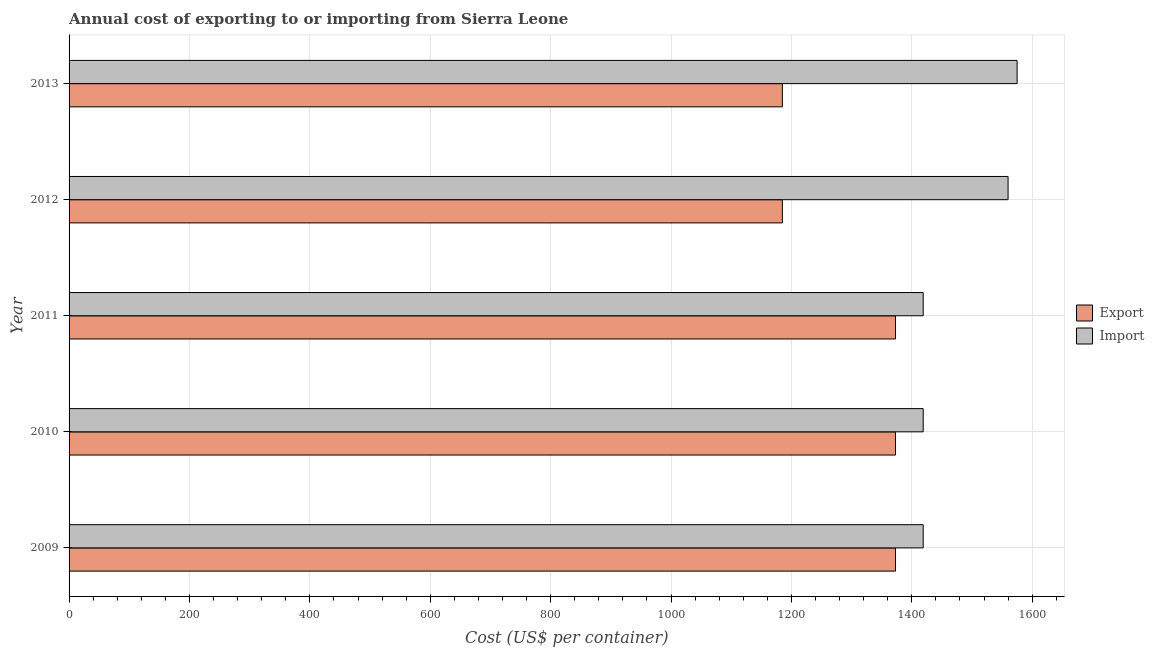How many different coloured bars are there?
Make the answer very short. 2. Are the number of bars per tick equal to the number of legend labels?
Your answer should be very brief. Yes. What is the label of the 5th group of bars from the top?
Offer a very short reply. 2009. What is the import cost in 2011?
Keep it short and to the point. 1419. Across all years, what is the maximum export cost?
Give a very brief answer. 1373. Across all years, what is the minimum import cost?
Give a very brief answer. 1419. What is the total import cost in the graph?
Provide a short and direct response. 7392. What is the difference between the export cost in 2010 and that in 2013?
Your answer should be compact. 188. What is the difference between the import cost in 2010 and the export cost in 2013?
Ensure brevity in your answer.  234. What is the average import cost per year?
Offer a very short reply. 1478.4. In the year 2013, what is the difference between the export cost and import cost?
Make the answer very short. -390. In how many years, is the import cost greater than 1600 US$?
Ensure brevity in your answer.  0. What is the ratio of the import cost in 2010 to that in 2011?
Give a very brief answer. 1. What is the difference between the highest and the lowest import cost?
Give a very brief answer. 156. In how many years, is the import cost greater than the average import cost taken over all years?
Ensure brevity in your answer.  2. What does the 1st bar from the top in 2009 represents?
Provide a succinct answer. Import. What does the 2nd bar from the bottom in 2013 represents?
Ensure brevity in your answer.  Import. Are the values on the major ticks of X-axis written in scientific E-notation?
Give a very brief answer. No. Does the graph contain grids?
Provide a short and direct response. Yes. How many legend labels are there?
Keep it short and to the point. 2. How are the legend labels stacked?
Your answer should be compact. Vertical. What is the title of the graph?
Offer a terse response. Annual cost of exporting to or importing from Sierra Leone. Does "Drinking water services" appear as one of the legend labels in the graph?
Offer a terse response. No. What is the label or title of the X-axis?
Keep it short and to the point. Cost (US$ per container). What is the Cost (US$ per container) of Export in 2009?
Make the answer very short. 1373. What is the Cost (US$ per container) in Import in 2009?
Provide a short and direct response. 1419. What is the Cost (US$ per container) in Export in 2010?
Offer a terse response. 1373. What is the Cost (US$ per container) in Import in 2010?
Offer a terse response. 1419. What is the Cost (US$ per container) of Export in 2011?
Provide a succinct answer. 1373. What is the Cost (US$ per container) in Import in 2011?
Provide a short and direct response. 1419. What is the Cost (US$ per container) of Export in 2012?
Offer a very short reply. 1185. What is the Cost (US$ per container) of Import in 2012?
Make the answer very short. 1560. What is the Cost (US$ per container) of Export in 2013?
Offer a terse response. 1185. What is the Cost (US$ per container) of Import in 2013?
Make the answer very short. 1575. Across all years, what is the maximum Cost (US$ per container) in Export?
Ensure brevity in your answer.  1373. Across all years, what is the maximum Cost (US$ per container) in Import?
Make the answer very short. 1575. Across all years, what is the minimum Cost (US$ per container) in Export?
Make the answer very short. 1185. Across all years, what is the minimum Cost (US$ per container) of Import?
Provide a succinct answer. 1419. What is the total Cost (US$ per container) of Export in the graph?
Offer a very short reply. 6489. What is the total Cost (US$ per container) in Import in the graph?
Ensure brevity in your answer.  7392. What is the difference between the Cost (US$ per container) of Export in 2009 and that in 2011?
Keep it short and to the point. 0. What is the difference between the Cost (US$ per container) of Export in 2009 and that in 2012?
Ensure brevity in your answer.  188. What is the difference between the Cost (US$ per container) in Import in 2009 and that in 2012?
Offer a very short reply. -141. What is the difference between the Cost (US$ per container) of Export in 2009 and that in 2013?
Make the answer very short. 188. What is the difference between the Cost (US$ per container) of Import in 2009 and that in 2013?
Ensure brevity in your answer.  -156. What is the difference between the Cost (US$ per container) in Export in 2010 and that in 2011?
Offer a terse response. 0. What is the difference between the Cost (US$ per container) of Import in 2010 and that in 2011?
Provide a succinct answer. 0. What is the difference between the Cost (US$ per container) in Export in 2010 and that in 2012?
Offer a terse response. 188. What is the difference between the Cost (US$ per container) in Import in 2010 and that in 2012?
Give a very brief answer. -141. What is the difference between the Cost (US$ per container) of Export in 2010 and that in 2013?
Give a very brief answer. 188. What is the difference between the Cost (US$ per container) in Import in 2010 and that in 2013?
Offer a terse response. -156. What is the difference between the Cost (US$ per container) of Export in 2011 and that in 2012?
Your response must be concise. 188. What is the difference between the Cost (US$ per container) of Import in 2011 and that in 2012?
Your answer should be compact. -141. What is the difference between the Cost (US$ per container) of Export in 2011 and that in 2013?
Give a very brief answer. 188. What is the difference between the Cost (US$ per container) in Import in 2011 and that in 2013?
Provide a short and direct response. -156. What is the difference between the Cost (US$ per container) of Export in 2012 and that in 2013?
Your answer should be compact. 0. What is the difference between the Cost (US$ per container) of Import in 2012 and that in 2013?
Make the answer very short. -15. What is the difference between the Cost (US$ per container) of Export in 2009 and the Cost (US$ per container) of Import in 2010?
Offer a terse response. -46. What is the difference between the Cost (US$ per container) of Export in 2009 and the Cost (US$ per container) of Import in 2011?
Make the answer very short. -46. What is the difference between the Cost (US$ per container) of Export in 2009 and the Cost (US$ per container) of Import in 2012?
Make the answer very short. -187. What is the difference between the Cost (US$ per container) in Export in 2009 and the Cost (US$ per container) in Import in 2013?
Offer a terse response. -202. What is the difference between the Cost (US$ per container) of Export in 2010 and the Cost (US$ per container) of Import in 2011?
Keep it short and to the point. -46. What is the difference between the Cost (US$ per container) in Export in 2010 and the Cost (US$ per container) in Import in 2012?
Offer a terse response. -187. What is the difference between the Cost (US$ per container) of Export in 2010 and the Cost (US$ per container) of Import in 2013?
Keep it short and to the point. -202. What is the difference between the Cost (US$ per container) of Export in 2011 and the Cost (US$ per container) of Import in 2012?
Your answer should be very brief. -187. What is the difference between the Cost (US$ per container) of Export in 2011 and the Cost (US$ per container) of Import in 2013?
Keep it short and to the point. -202. What is the difference between the Cost (US$ per container) of Export in 2012 and the Cost (US$ per container) of Import in 2013?
Ensure brevity in your answer.  -390. What is the average Cost (US$ per container) of Export per year?
Provide a short and direct response. 1297.8. What is the average Cost (US$ per container) of Import per year?
Your answer should be very brief. 1478.4. In the year 2009, what is the difference between the Cost (US$ per container) in Export and Cost (US$ per container) in Import?
Your answer should be compact. -46. In the year 2010, what is the difference between the Cost (US$ per container) of Export and Cost (US$ per container) of Import?
Your answer should be very brief. -46. In the year 2011, what is the difference between the Cost (US$ per container) in Export and Cost (US$ per container) in Import?
Offer a terse response. -46. In the year 2012, what is the difference between the Cost (US$ per container) of Export and Cost (US$ per container) of Import?
Provide a short and direct response. -375. In the year 2013, what is the difference between the Cost (US$ per container) in Export and Cost (US$ per container) in Import?
Provide a succinct answer. -390. What is the ratio of the Cost (US$ per container) of Import in 2009 to that in 2010?
Your answer should be compact. 1. What is the ratio of the Cost (US$ per container) in Import in 2009 to that in 2011?
Keep it short and to the point. 1. What is the ratio of the Cost (US$ per container) in Export in 2009 to that in 2012?
Offer a terse response. 1.16. What is the ratio of the Cost (US$ per container) of Import in 2009 to that in 2012?
Keep it short and to the point. 0.91. What is the ratio of the Cost (US$ per container) of Export in 2009 to that in 2013?
Provide a short and direct response. 1.16. What is the ratio of the Cost (US$ per container) in Import in 2009 to that in 2013?
Offer a terse response. 0.9. What is the ratio of the Cost (US$ per container) in Export in 2010 to that in 2011?
Ensure brevity in your answer.  1. What is the ratio of the Cost (US$ per container) in Export in 2010 to that in 2012?
Provide a succinct answer. 1.16. What is the ratio of the Cost (US$ per container) of Import in 2010 to that in 2012?
Keep it short and to the point. 0.91. What is the ratio of the Cost (US$ per container) of Export in 2010 to that in 2013?
Provide a short and direct response. 1.16. What is the ratio of the Cost (US$ per container) in Import in 2010 to that in 2013?
Offer a very short reply. 0.9. What is the ratio of the Cost (US$ per container) in Export in 2011 to that in 2012?
Provide a succinct answer. 1.16. What is the ratio of the Cost (US$ per container) of Import in 2011 to that in 2012?
Offer a terse response. 0.91. What is the ratio of the Cost (US$ per container) of Export in 2011 to that in 2013?
Keep it short and to the point. 1.16. What is the ratio of the Cost (US$ per container) of Import in 2011 to that in 2013?
Offer a terse response. 0.9. What is the ratio of the Cost (US$ per container) in Export in 2012 to that in 2013?
Ensure brevity in your answer.  1. What is the difference between the highest and the second highest Cost (US$ per container) in Import?
Offer a very short reply. 15. What is the difference between the highest and the lowest Cost (US$ per container) in Export?
Provide a succinct answer. 188. What is the difference between the highest and the lowest Cost (US$ per container) in Import?
Make the answer very short. 156. 